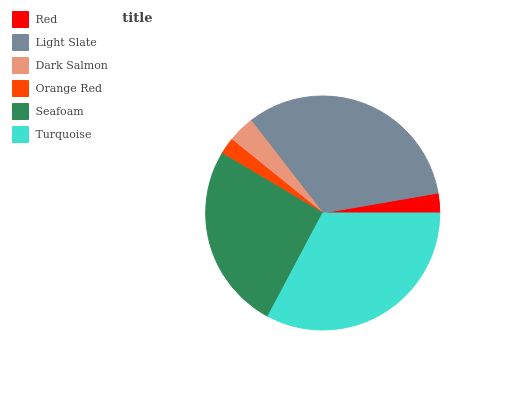Is Orange Red the minimum?
Answer yes or no. Yes. Is Light Slate the maximum?
Answer yes or no. Yes. Is Dark Salmon the minimum?
Answer yes or no. No. Is Dark Salmon the maximum?
Answer yes or no. No. Is Light Slate greater than Dark Salmon?
Answer yes or no. Yes. Is Dark Salmon less than Light Slate?
Answer yes or no. Yes. Is Dark Salmon greater than Light Slate?
Answer yes or no. No. Is Light Slate less than Dark Salmon?
Answer yes or no. No. Is Seafoam the high median?
Answer yes or no. Yes. Is Dark Salmon the low median?
Answer yes or no. Yes. Is Light Slate the high median?
Answer yes or no. No. Is Red the low median?
Answer yes or no. No. 